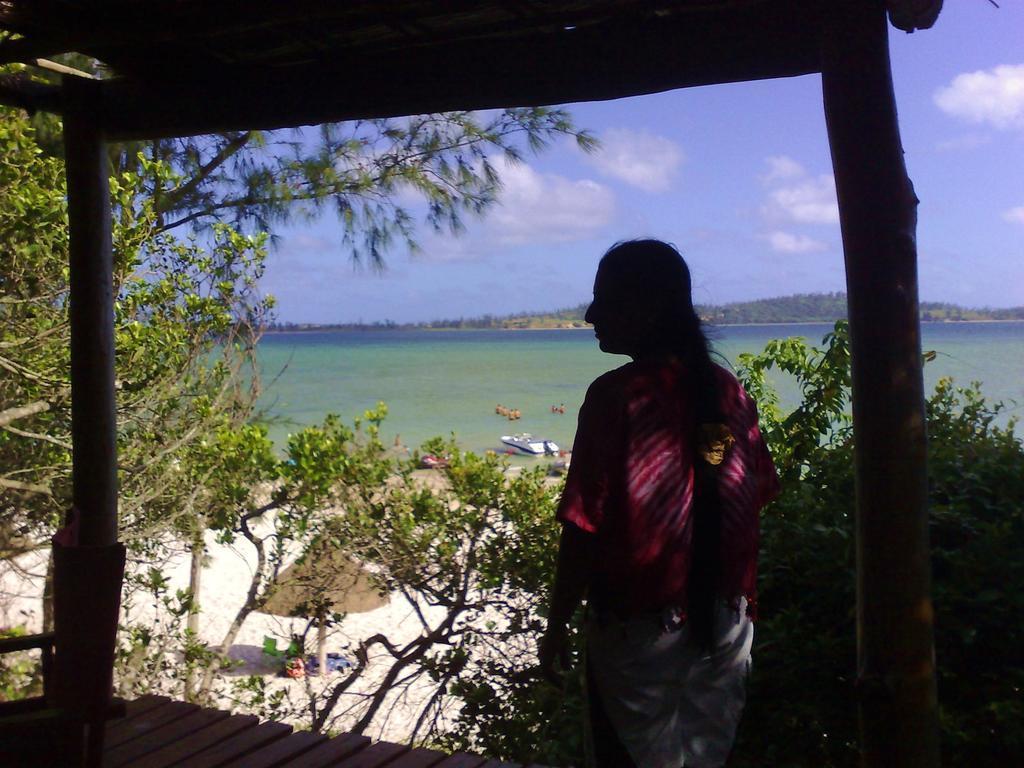Could you give a brief overview of what you see in this image? In this image I can see a person is standing. I can also see wooden poles, trees and some objects on the ground. In the background I can see a boat on the water and the sky. 